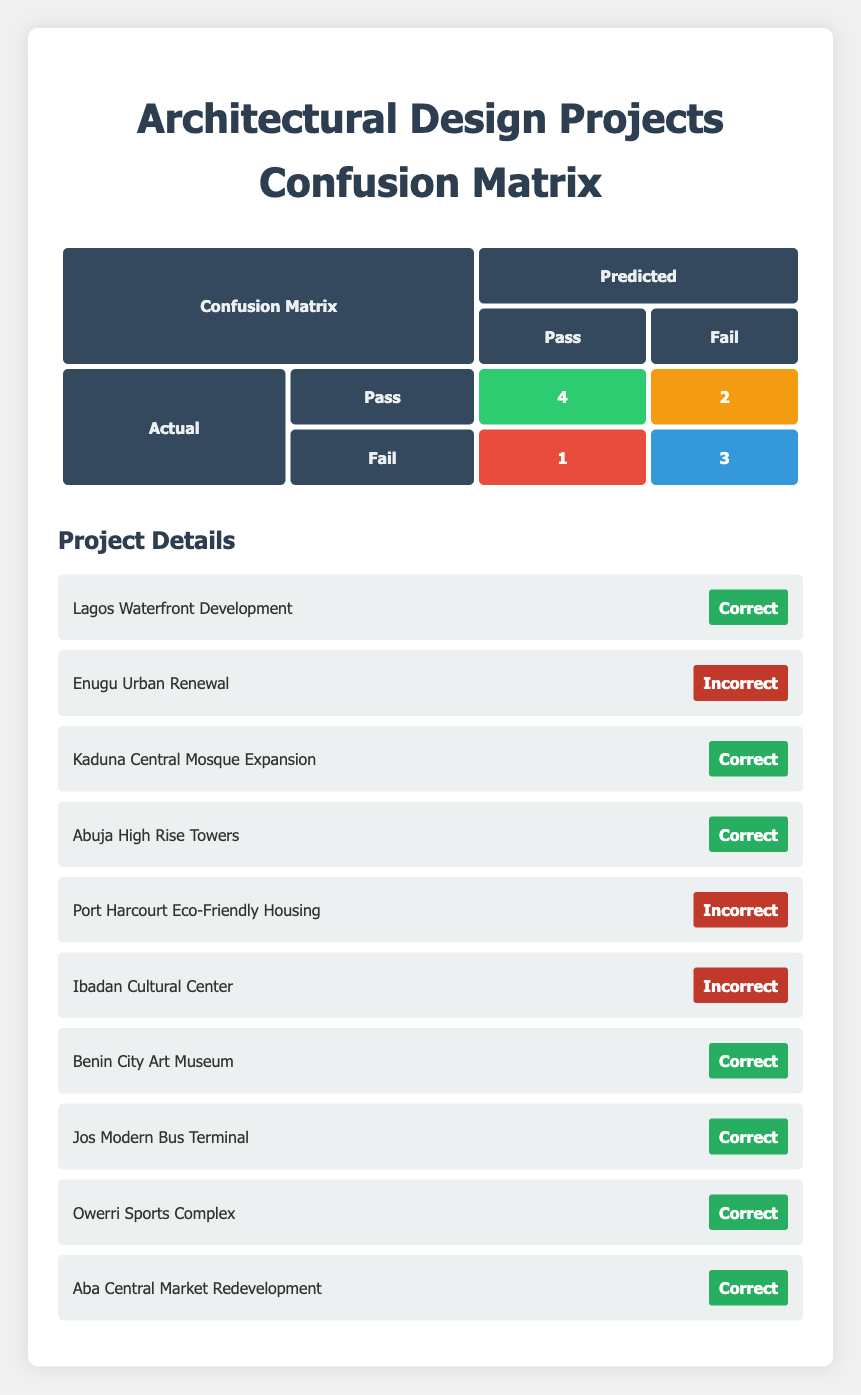What is the number of true positives in the confusion matrix? The true positives represent the number of projects that were actually classified as "Pass" and were also predicted to be "Pass." Looking at the matrix, the value in the true positive cell is 4.
Answer: 4 How many projects were incorrectly predicted as "Fail"? To find the incorrectly predicted "Fail" projects, we need to look at the false positive cell, which is the count of projects that were actually "Fail" but predicted as "Pass." The value in the false positive cell is 1.
Answer: 1 What is the total number of projects that received a passing classification? The total passing classifications include true positives and false negatives. Looking at the true positive value (4) and the false negative value (2), we can sum these: 4 + 2 = 6.
Answer: 6 Did any project have a false negative prediction? A false negative occurs when a project that should have been classified as "Pass" was classified as "Fail." Given that there are 2 false negatives in the matrix, the answer is yes.
Answer: Yes What is the total number of true negatives? True negatives refer to the projects that were actually "Fail" and were also predicted as "Fail." According to the confusion matrix, the value in the true negative cell is 3.
Answer: 3 What is the difference between true positives and false negatives? The true positives are 4, and the false negatives are 2. The difference is calculated by subtracting the false negatives from the true positives: 4 - 2 = 2.
Answer: 2 How many total predictions were made for "Pass"? Total predictions for "Pass" include true positives and false positives. From the matrix, true positives (4) and false positives (1) give us a total of 4 + 1 = 5 predictions for "Pass."
Answer: 5 What percentage of the projects were correctly predicted as "Pass"? Correct predictions for "Pass" are the true positives (4). To find the percentage, we divide the true positives by the total number of projects (10), giving us (4 / 10) * 100 = 40%.
Answer: 40% Which project was incorrectly predicted, receiving a "Fail" instead of "Pass"? The project "Enugu Urban Renewal" was actually "Pass," but it was predicted as "Fail," which represents one of the instances of incorrect prediction.
Answer: Enugu Urban Renewal 